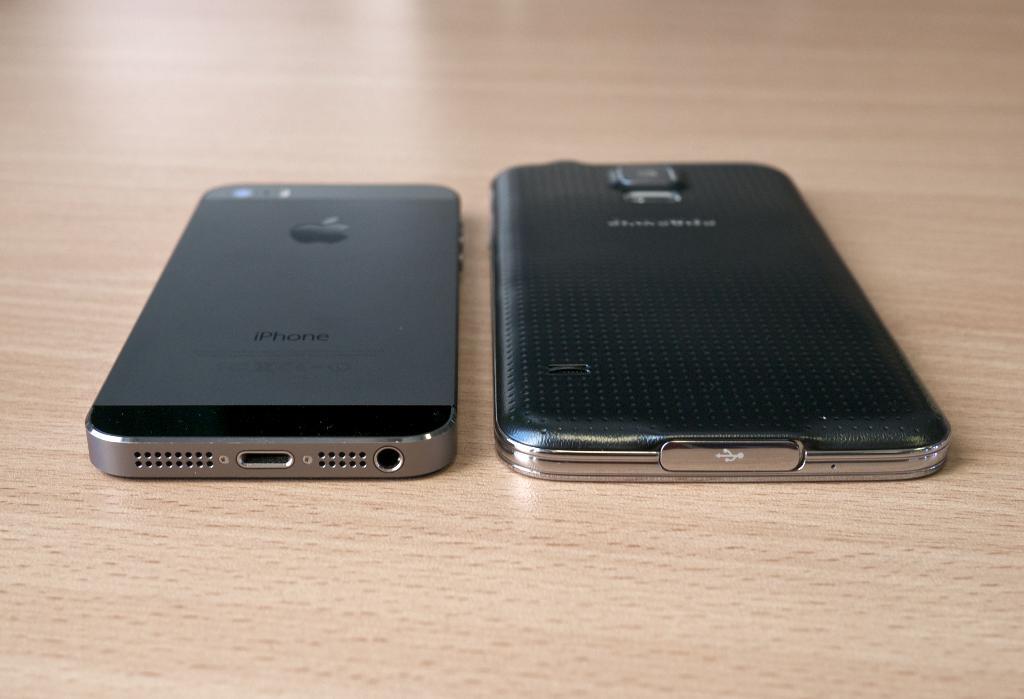What is the first lower case letter on the phone to the left?
Your answer should be very brief. I. What phone type is this?
Provide a succinct answer. Iphone. 